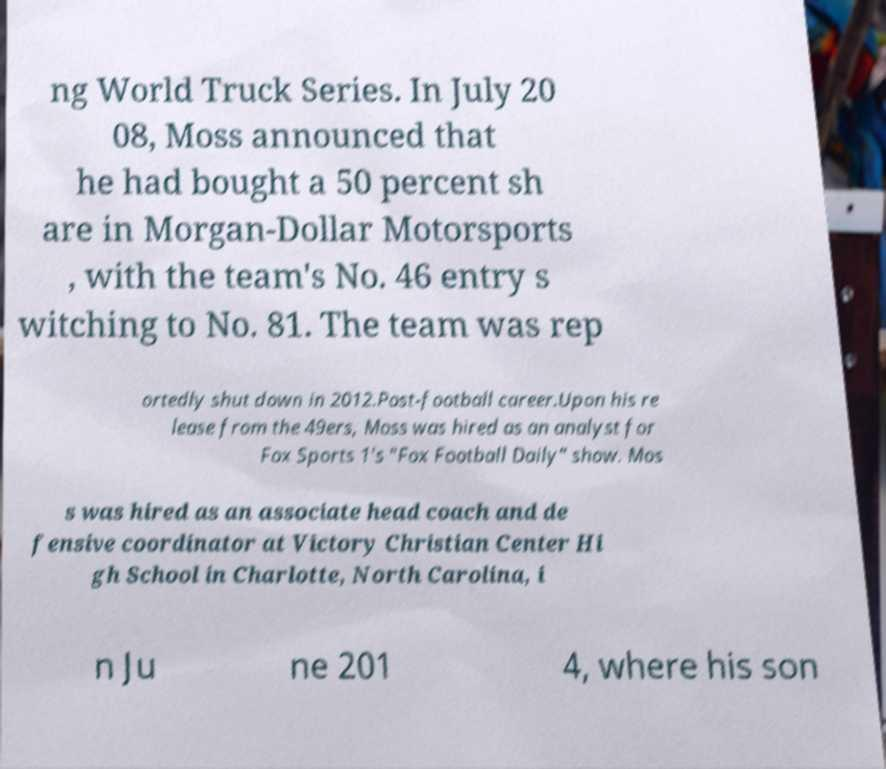For documentation purposes, I need the text within this image transcribed. Could you provide that? ng World Truck Series. In July 20 08, Moss announced that he had bought a 50 percent sh are in Morgan-Dollar Motorsports , with the team's No. 46 entry s witching to No. 81. The team was rep ortedly shut down in 2012.Post-football career.Upon his re lease from the 49ers, Moss was hired as an analyst for Fox Sports 1's "Fox Football Daily" show. Mos s was hired as an associate head coach and de fensive coordinator at Victory Christian Center Hi gh School in Charlotte, North Carolina, i n Ju ne 201 4, where his son 